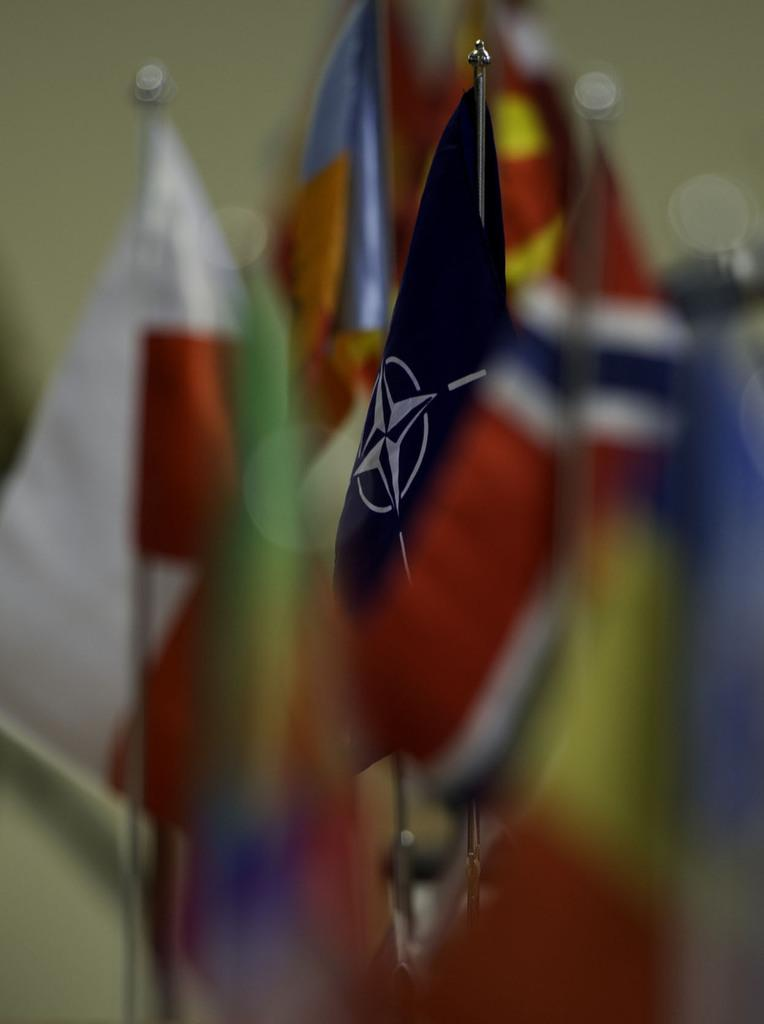What is the overall quality of the image? The image is blurry. What can be seen in the image despite the blurriness? There are multiple flags in the image. Is there any specific flag that stands out? One of the flags is highlighted. What type of game is being played in the image? There is no game being played in the image; it features multiple flags, some of which are blurry and one of which is highlighted. 